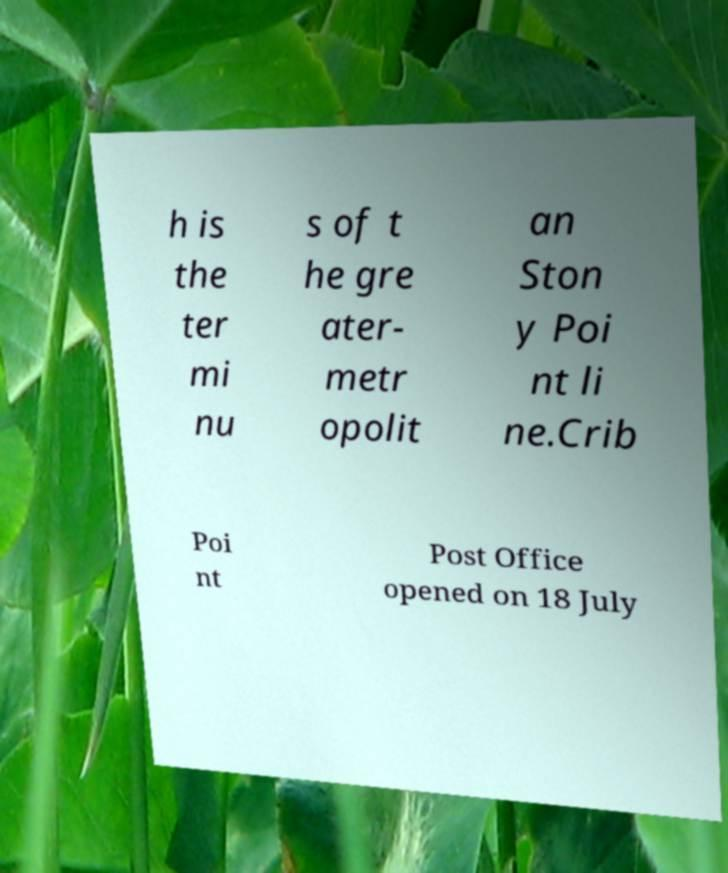Could you assist in decoding the text presented in this image and type it out clearly? h is the ter mi nu s of t he gre ater- metr opolit an Ston y Poi nt li ne.Crib Poi nt Post Office opened on 18 July 